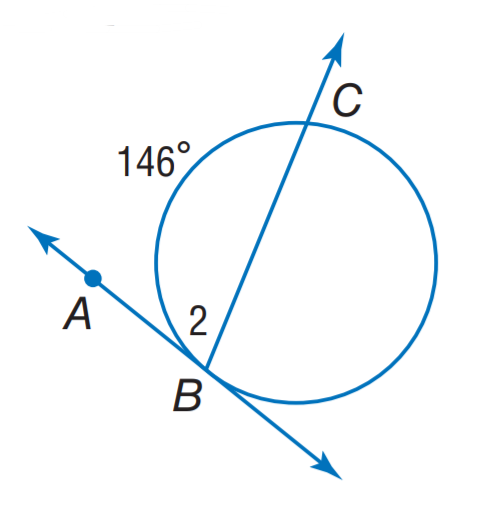Answer the mathemtical geometry problem and directly provide the correct option letter.
Question: Find m \angle 2.
Choices: A: 73 B: 82 C: 107 D: 146 A 